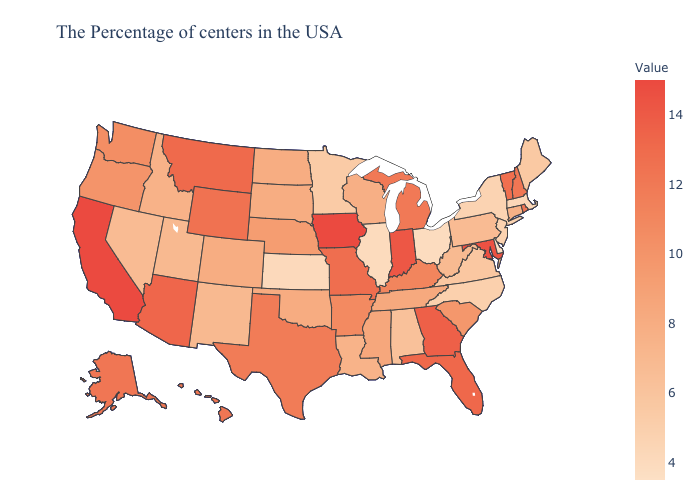Among the states that border Indiana , does Ohio have the lowest value?
Be succinct. Yes. Does Maryland have the highest value in the South?
Write a very short answer. Yes. Which states have the highest value in the USA?
Write a very short answer. Iowa, California. Does Iowa have the highest value in the USA?
Quick response, please. Yes. Which states hav the highest value in the MidWest?
Quick response, please. Iowa. 